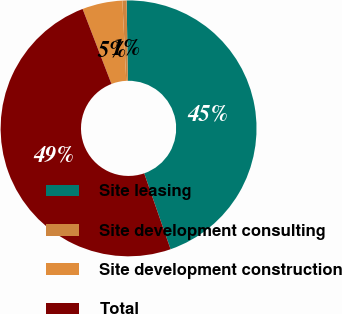Convert chart to OTSL. <chart><loc_0><loc_0><loc_500><loc_500><pie_chart><fcel>Site leasing<fcel>Site development consulting<fcel>Site development construction<fcel>Total<nl><fcel>44.92%<fcel>0.53%<fcel>5.08%<fcel>49.47%<nl></chart> 